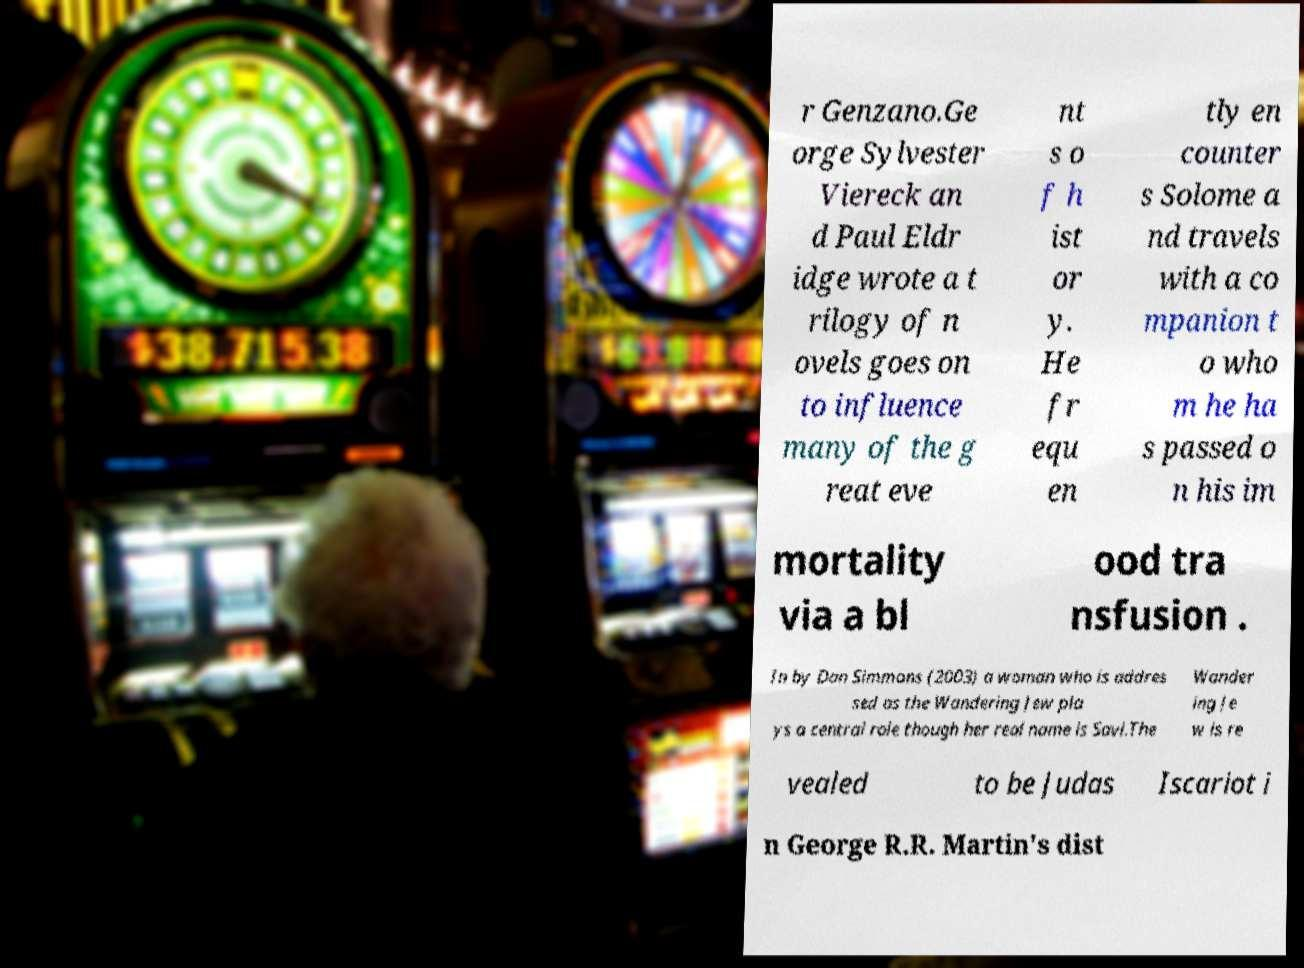Can you read and provide the text displayed in the image?This photo seems to have some interesting text. Can you extract and type it out for me? r Genzano.Ge orge Sylvester Viereck an d Paul Eldr idge wrote a t rilogy of n ovels goes on to influence many of the g reat eve nt s o f h ist or y. He fr equ en tly en counter s Solome a nd travels with a co mpanion t o who m he ha s passed o n his im mortality via a bl ood tra nsfusion . In by Dan Simmons (2003) a woman who is addres sed as the Wandering Jew pla ys a central role though her real name is Savi.The Wander ing Je w is re vealed to be Judas Iscariot i n George R.R. Martin's dist 